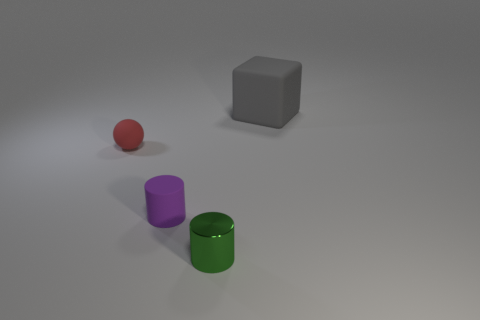What shape is the red thing that is the same size as the purple cylinder?
Ensure brevity in your answer.  Sphere. How many things are either tiny brown matte things or tiny things that are right of the tiny rubber sphere?
Offer a very short reply. 2. There is a object left of the small purple rubber object in front of the sphere; what number of small red objects are in front of it?
Your response must be concise. 0. What color is the sphere that is the same material as the tiny purple cylinder?
Your response must be concise. Red. Do the cylinder that is in front of the matte cylinder and the tiny red thing have the same size?
Provide a short and direct response. Yes. How many objects are either large matte blocks or cyan cylinders?
Provide a succinct answer. 1. The thing that is left of the tiny rubber cylinder behind the tiny green metallic object on the right side of the red matte sphere is made of what material?
Provide a short and direct response. Rubber. What is the big object that is to the right of the red sphere made of?
Offer a terse response. Rubber. Is there a green metal thing of the same size as the matte sphere?
Your answer should be very brief. Yes. Is the color of the small rubber thing in front of the small red matte sphere the same as the shiny thing?
Provide a short and direct response. No. 